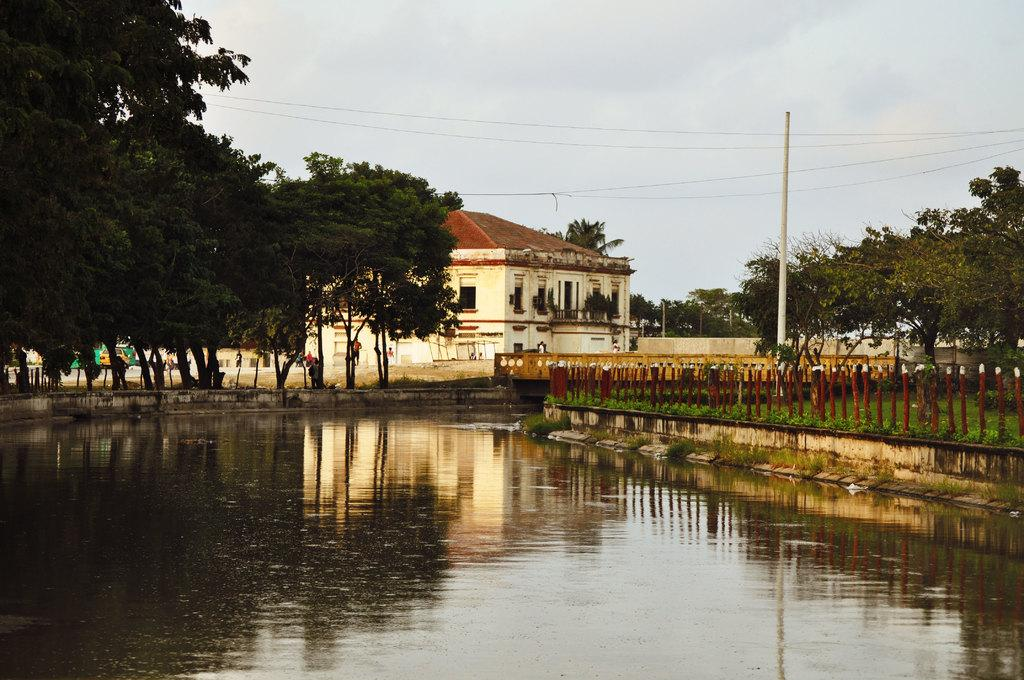What type of natural feature can be seen in the picture? There is a lake in the picture. What type of vegetation is present in the picture? There are trees in the picture. What type of man-made structure is visible in the picture? There is a building in the picture. What other object can be seen in the picture? There is a pole in the picture. What is the condition of the sky in the picture? The sky is clear in the picture. How many eggs are being held by the sisters in the picture? There are no sisters or eggs present in the picture. What type of plants are growing near the lake in the picture? The provided facts do not mention any plants near the lake, so we cannot answer this question definitively. 